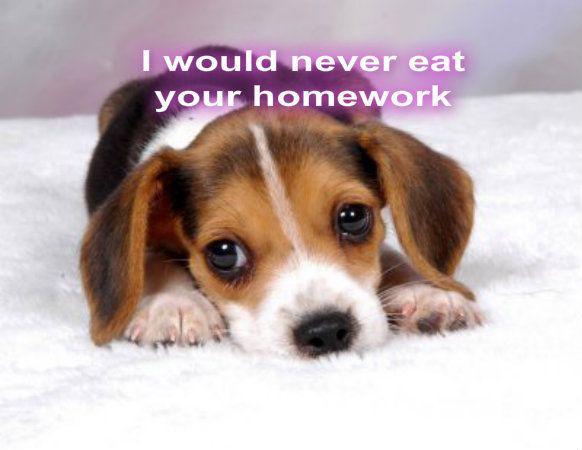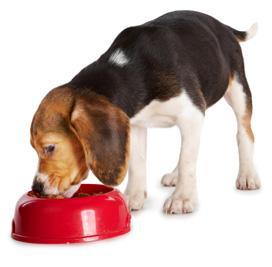The first image is the image on the left, the second image is the image on the right. Analyze the images presented: Is the assertion "A beagle is eating sausages." valid? Answer yes or no. No. 